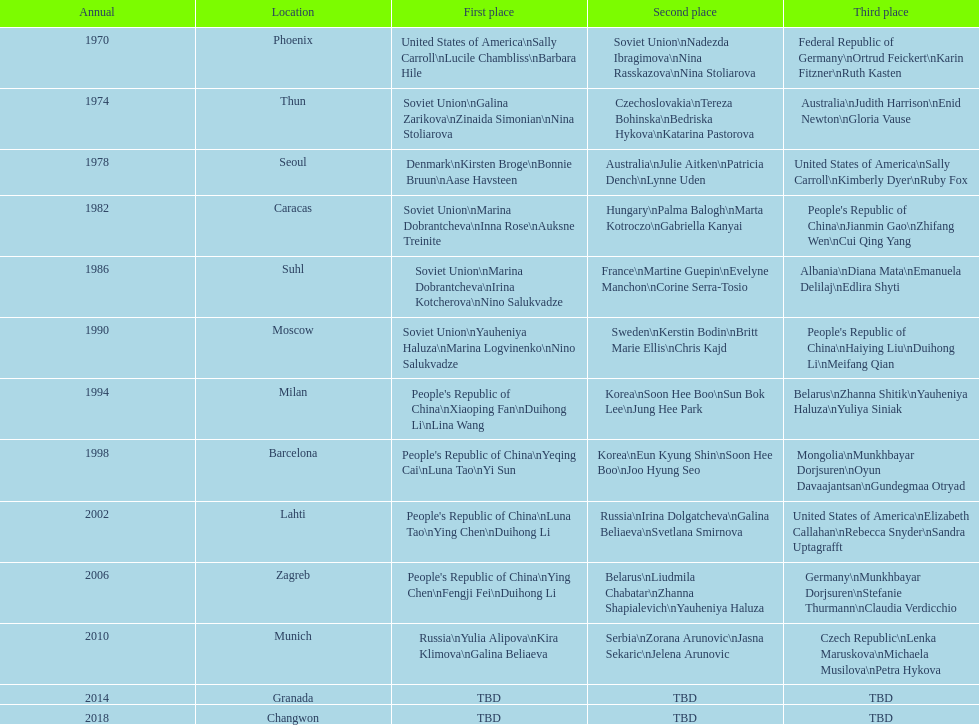What is the number of total bronze medals that germany has won? 1. 